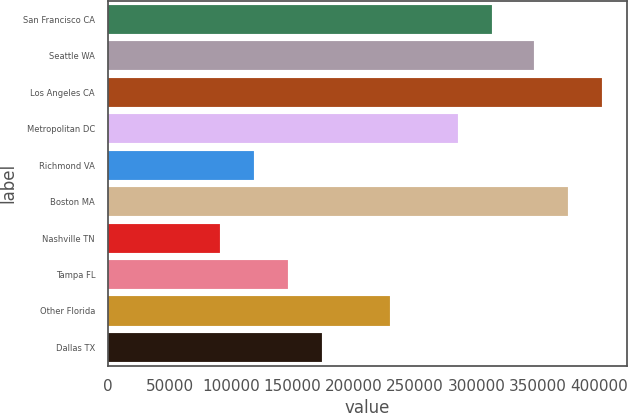Convert chart to OTSL. <chart><loc_0><loc_0><loc_500><loc_500><bar_chart><fcel>San Francisco CA<fcel>Seattle WA<fcel>Los Angeles CA<fcel>Metropolitan DC<fcel>Richmond VA<fcel>Boston MA<fcel>Nashville TN<fcel>Tampa FL<fcel>Other Florida<fcel>Dallas TX<nl><fcel>313022<fcel>346894<fcel>402298<fcel>285319<fcel>119106<fcel>374596<fcel>91404<fcel>146808<fcel>229915<fcel>174511<nl></chart> 